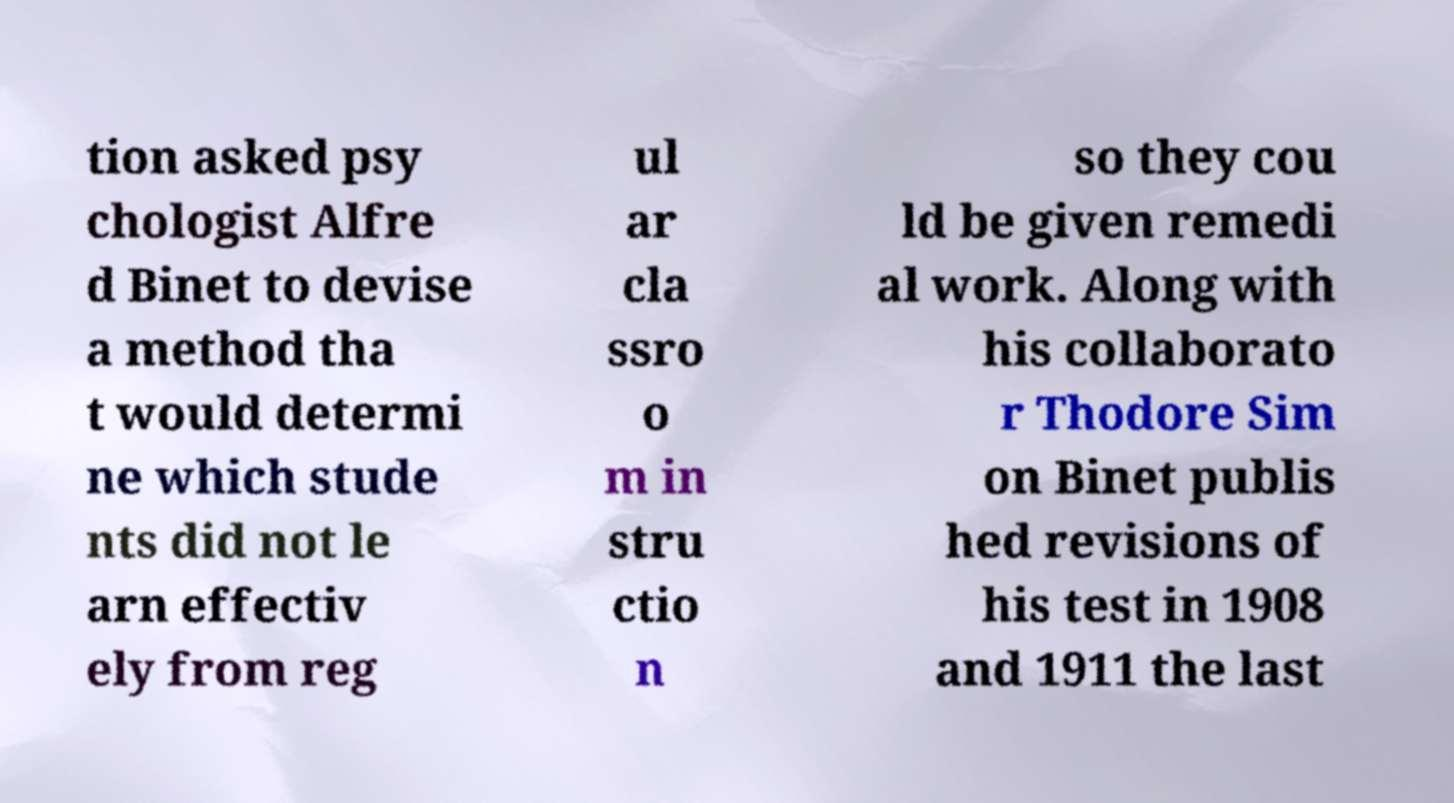Please read and relay the text visible in this image. What does it say? tion asked psy chologist Alfre d Binet to devise a method tha t would determi ne which stude nts did not le arn effectiv ely from reg ul ar cla ssro o m in stru ctio n so they cou ld be given remedi al work. Along with his collaborato r Thodore Sim on Binet publis hed revisions of his test in 1908 and 1911 the last 